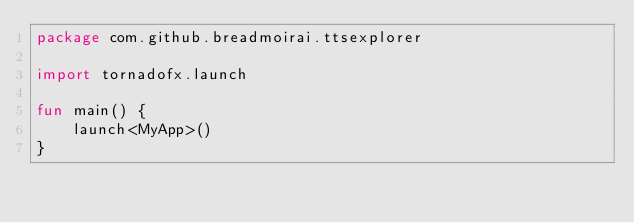Convert code to text. <code><loc_0><loc_0><loc_500><loc_500><_Kotlin_>package com.github.breadmoirai.ttsexplorer

import tornadofx.launch

fun main() {
    launch<MyApp>()
}</code> 